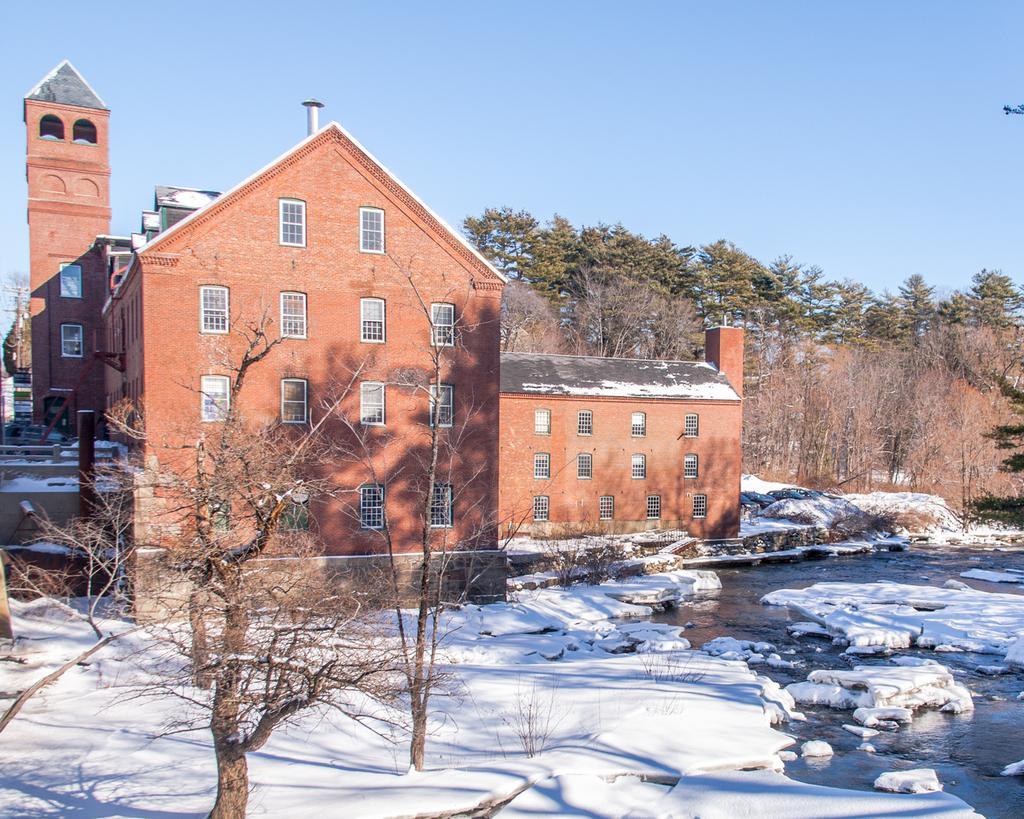How would you summarize this image in a sentence or two? In this image we can see a house with windows. There are trees. At the bottom of the image there is snow, water. At the top of the image there is sky. 